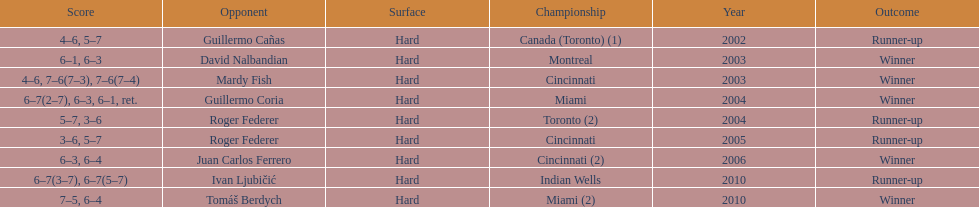On how many occasions were roddick's competitors not from the usa? 8. 